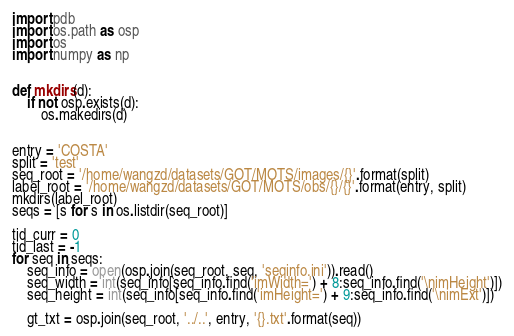<code> <loc_0><loc_0><loc_500><loc_500><_Python_>import pdb
import os.path as osp
import os
import numpy as np


def mkdirs(d):
    if not osp.exists(d):
        os.makedirs(d)


entry = 'COSTA'
split = 'test'
seq_root = '/home/wangzd/datasets/GOT/MOTS/images/{}'.format(split)
label_root = '/home/wangzd/datasets/GOT/MOTS/obs/{}/{}'.format(entry, split)
mkdirs(label_root)
seqs = [s for s in os.listdir(seq_root)]

tid_curr = 0
tid_last = -1
for seq in seqs:
    seq_info = open(osp.join(seq_root, seq, 'seqinfo.ini')).read()
    seq_width = int(seq_info[seq_info.find('imWidth=') + 8:seq_info.find('\nimHeight')])
    seq_height = int(seq_info[seq_info.find('imHeight=') + 9:seq_info.find('\nimExt')])

    gt_txt = osp.join(seq_root, '../..', entry, '{}.txt'.format(seq))</code> 